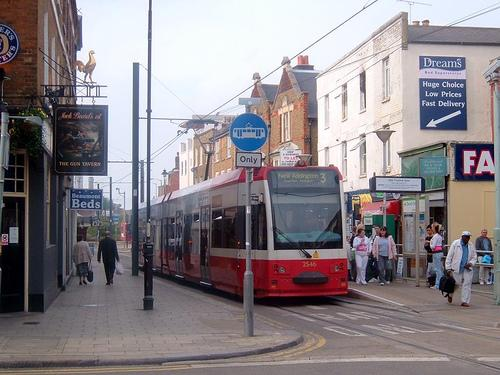In which location does this bus run? Please explain your reasoning. city. There are big buildings and a lot of people in the street. 